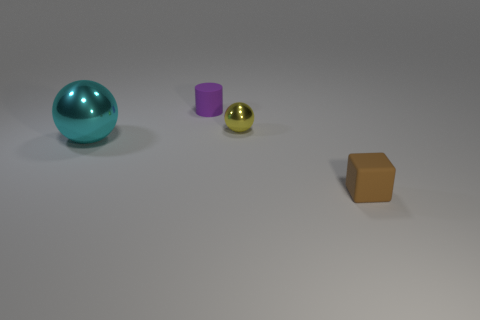Are there an equal number of matte things behind the purple cylinder and rubber cylinders?
Your answer should be compact. No. What shape is the brown thing that is the same size as the yellow metal object?
Provide a succinct answer. Cube. How many other things are the same shape as the brown matte thing?
Offer a terse response. 0. There is a purple cylinder; is it the same size as the shiny sphere left of the yellow thing?
Provide a short and direct response. No. How many objects are cyan balls that are in front of the yellow ball or purple cylinders?
Make the answer very short. 2. There is a rubber object in front of the yellow metal thing; what is its shape?
Provide a succinct answer. Cube. Are there an equal number of objects behind the tiny brown thing and purple things that are right of the small metallic thing?
Make the answer very short. No. There is a object that is to the left of the tiny metal thing and in front of the tiny purple matte cylinder; what color is it?
Your response must be concise. Cyan. What is the thing left of the matte object that is left of the small brown cube made of?
Your answer should be compact. Metal. Does the cyan thing have the same size as the cylinder?
Ensure brevity in your answer.  No. 